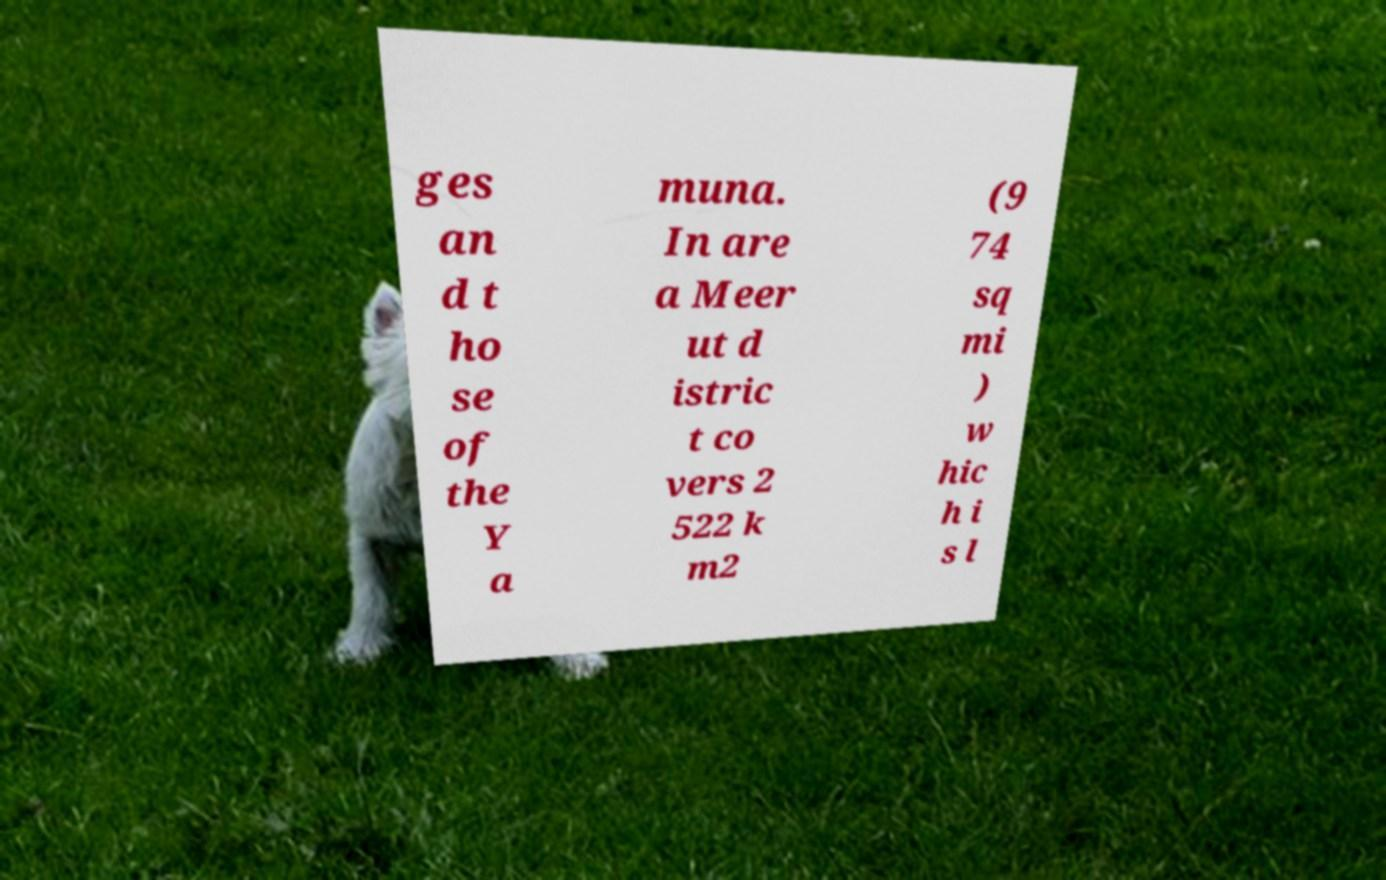Can you read and provide the text displayed in the image?This photo seems to have some interesting text. Can you extract and type it out for me? ges an d t ho se of the Y a muna. In are a Meer ut d istric t co vers 2 522 k m2 (9 74 sq mi ) w hic h i s l 